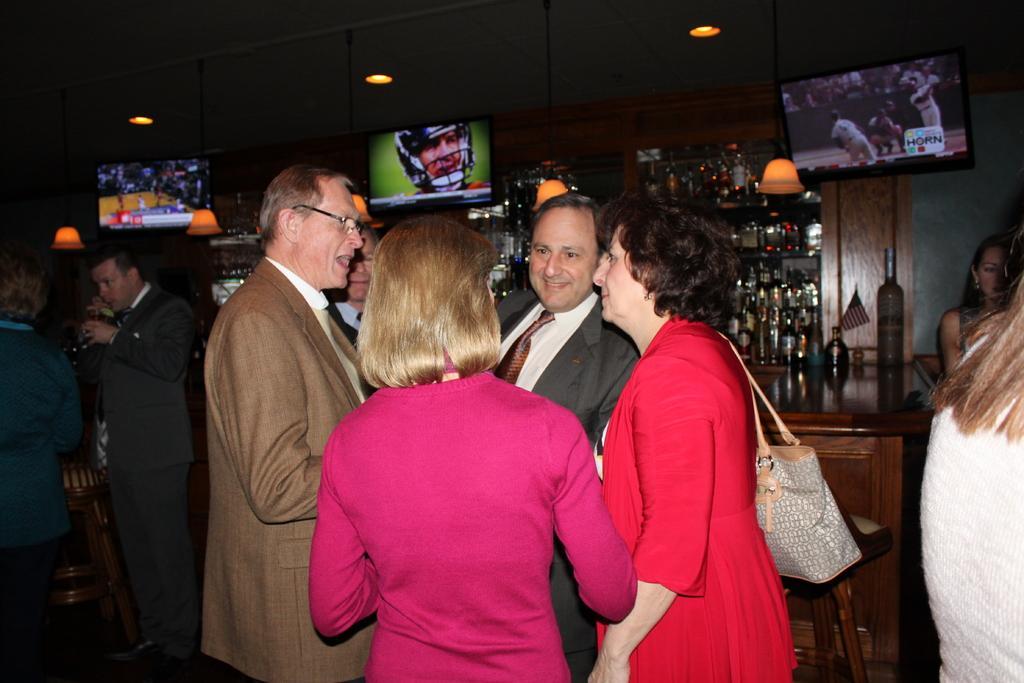Can you describe this image briefly? In this image we can see people standing on the floor. In the background there are beverage bottles in the shelves, display screens and electric lights. 